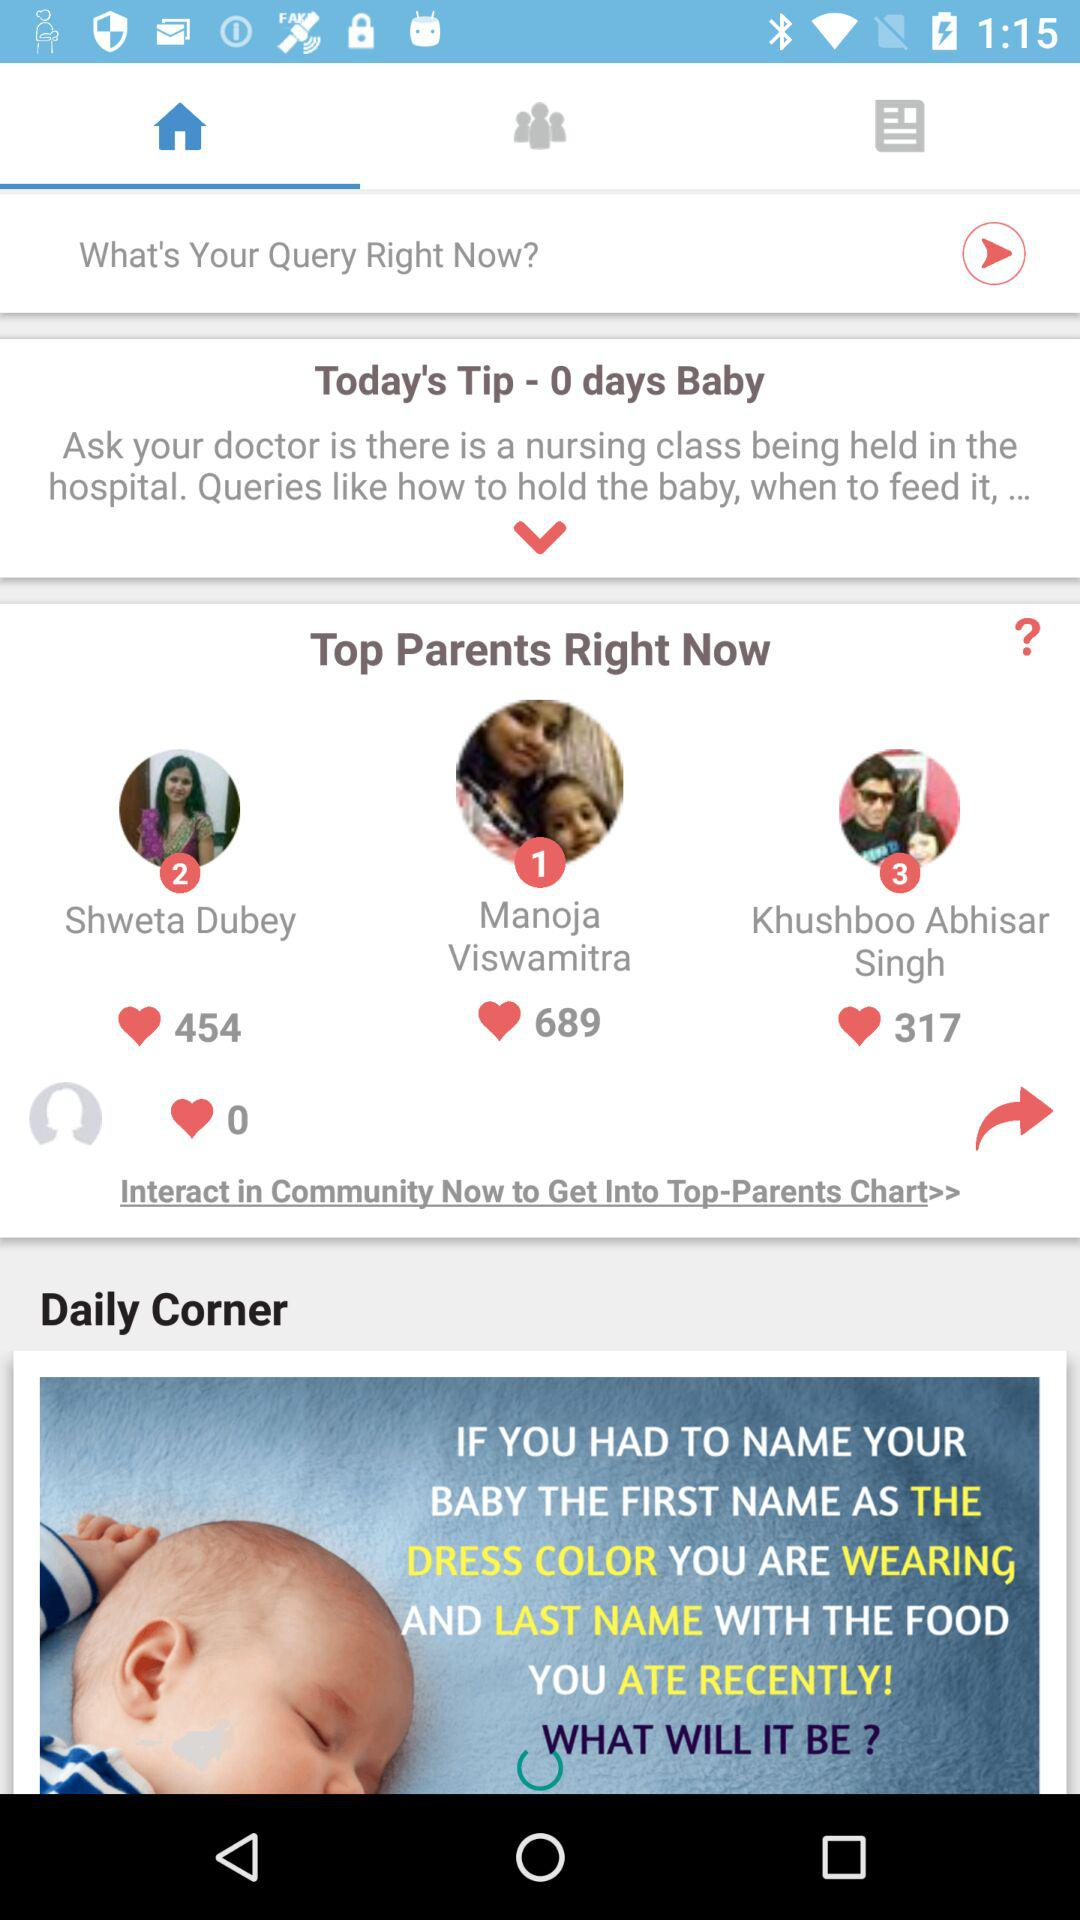How many likes did top parent number 1 receive? Top parent number 1 receives 689 likes. 